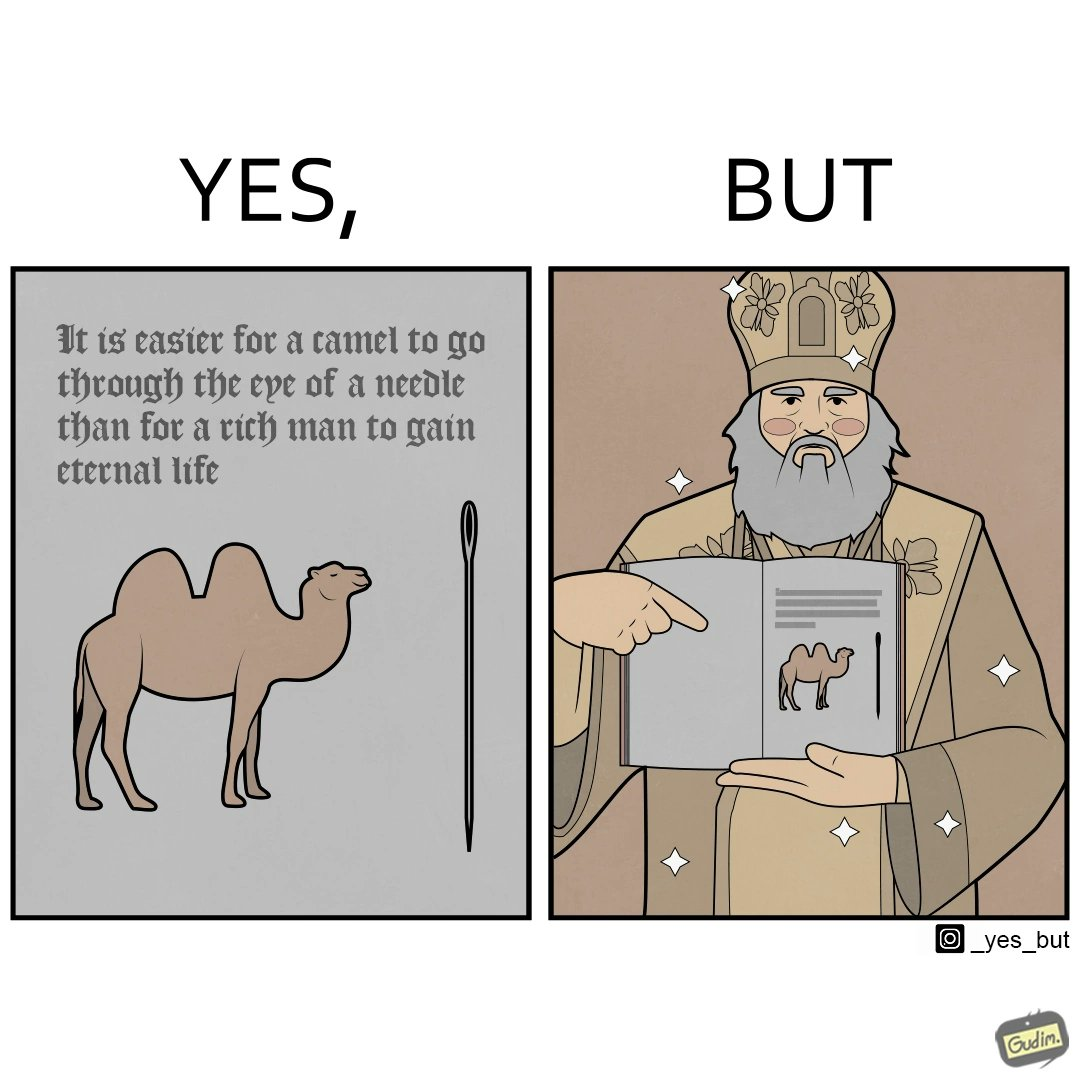What makes this image funny or satirical? The image is ironic, because an old man with good looking clothes, symbolising him as rich, is showing a quote on the difficulty for a rich man to gain eternal life whereas the man has both long life meaning eternal life and good clothes meaning rich 